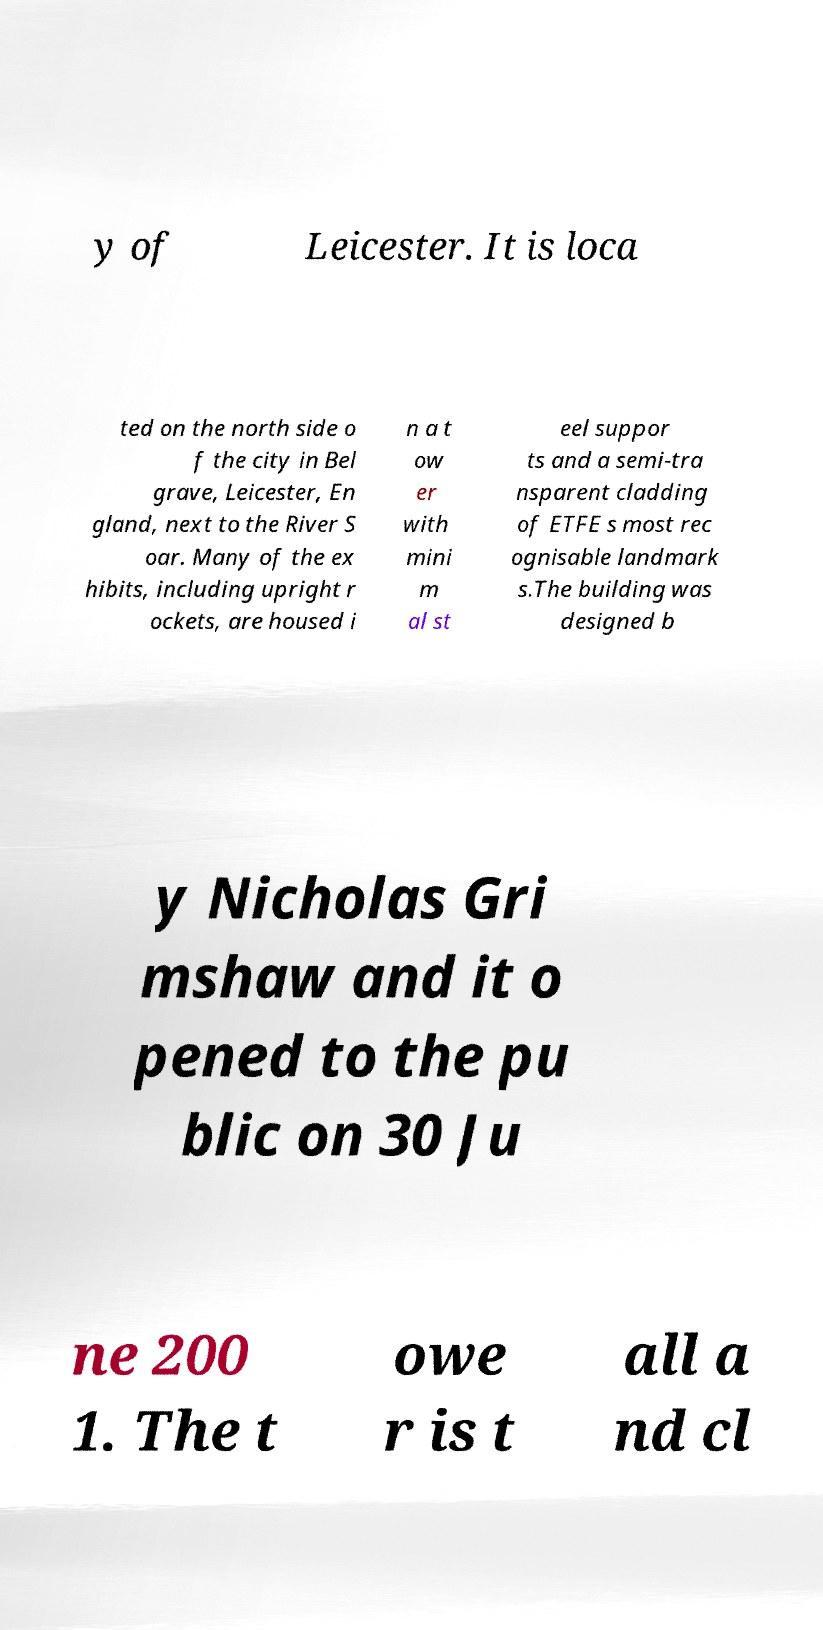Can you read and provide the text displayed in the image?This photo seems to have some interesting text. Can you extract and type it out for me? y of Leicester. It is loca ted on the north side o f the city in Bel grave, Leicester, En gland, next to the River S oar. Many of the ex hibits, including upright r ockets, are housed i n a t ow er with mini m al st eel suppor ts and a semi-tra nsparent cladding of ETFE s most rec ognisable landmark s.The building was designed b y Nicholas Gri mshaw and it o pened to the pu blic on 30 Ju ne 200 1. The t owe r is t all a nd cl 